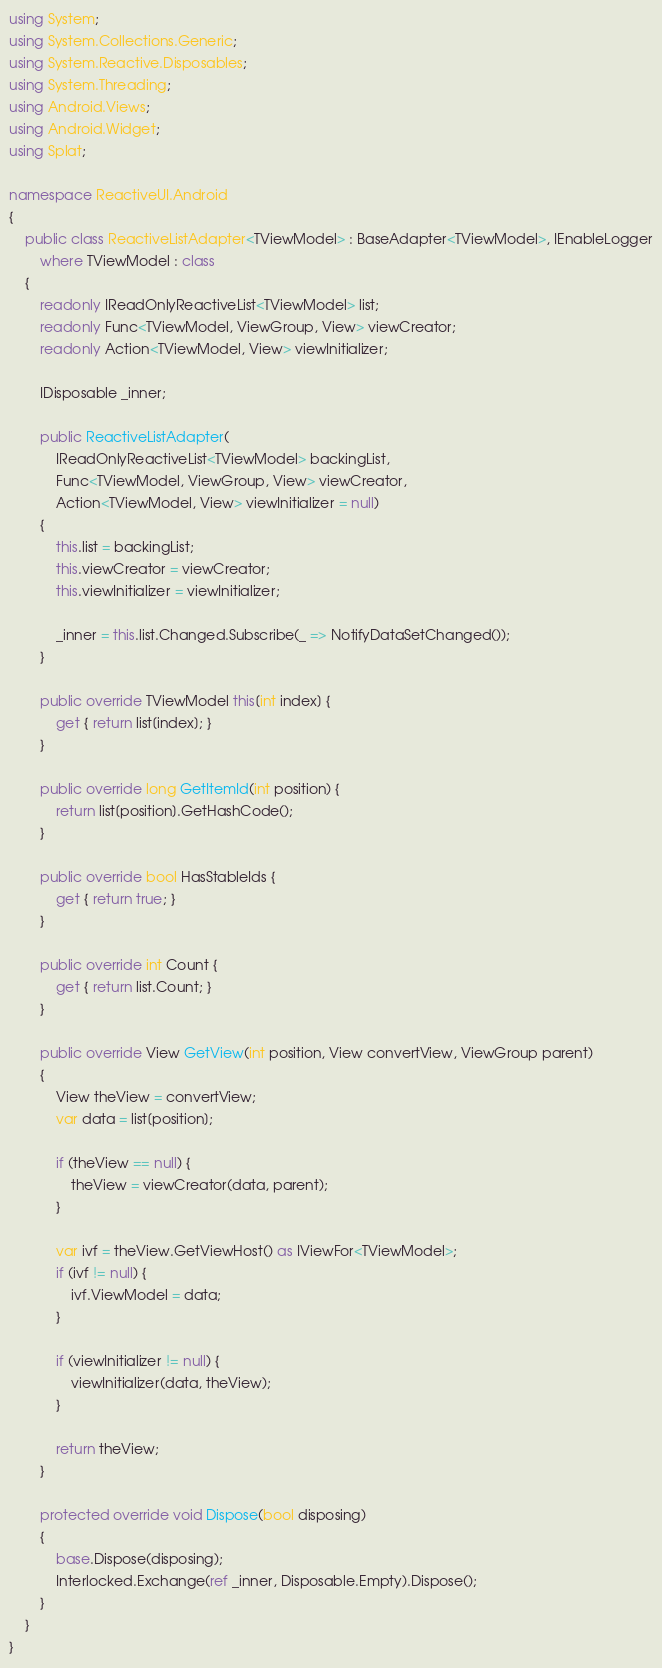Convert code to text. <code><loc_0><loc_0><loc_500><loc_500><_C#_>using System;
using System.Collections.Generic;
using System.Reactive.Disposables;
using System.Threading;
using Android.Views;
using Android.Widget;
using Splat;

namespace ReactiveUI.Android
{
    public class ReactiveListAdapter<TViewModel> : BaseAdapter<TViewModel>, IEnableLogger
        where TViewModel : class
    {
        readonly IReadOnlyReactiveList<TViewModel> list;
        readonly Func<TViewModel, ViewGroup, View> viewCreator;
        readonly Action<TViewModel, View> viewInitializer;

        IDisposable _inner;

        public ReactiveListAdapter(
            IReadOnlyReactiveList<TViewModel> backingList,
            Func<TViewModel, ViewGroup, View> viewCreator,
            Action<TViewModel, View> viewInitializer = null)
        {
            this.list = backingList;
            this.viewCreator = viewCreator;
            this.viewInitializer = viewInitializer;

            _inner = this.list.Changed.Subscribe(_ => NotifyDataSetChanged());
        }

        public override TViewModel this[int index] {
            get { return list[index]; }
        }

        public override long GetItemId(int position) {
            return list[position].GetHashCode();
        }

        public override bool HasStableIds {
            get { return true; }
        }

        public override int Count {
            get { return list.Count; }
        }

        public override View GetView(int position, View convertView, ViewGroup parent)
        {
            View theView = convertView;
            var data = list[position];

            if (theView == null) {
                theView = viewCreator(data, parent);
            }

            var ivf = theView.GetViewHost() as IViewFor<TViewModel>;
            if (ivf != null) {
                ivf.ViewModel = data;
            }

            if (viewInitializer != null) {
                viewInitializer(data, theView);
            }

            return theView;
        }

        protected override void Dispose(bool disposing)
        {
            base.Dispose(disposing);
            Interlocked.Exchange(ref _inner, Disposable.Empty).Dispose();
        }
    }
}</code> 